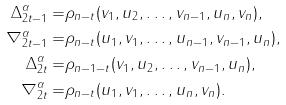<formula> <loc_0><loc_0><loc_500><loc_500>\Delta ^ { \alpha } _ { 2 t - 1 } = & \rho _ { n - t } ( v _ { 1 } , u _ { 2 } , \dots , v _ { n - 1 } , u _ { n } , v _ { n } ) , \\ \nabla ^ { \alpha } _ { 2 t - 1 } = & \rho _ { n - t } ( u _ { 1 } , v _ { 1 } , \dots , u _ { n - 1 } , v _ { n - 1 } , u _ { n } ) , \\ \Delta ^ { \alpha } _ { 2 t } = & \rho _ { n - 1 - t } ( v _ { 1 } , u _ { 2 } , \dots , v _ { n - 1 } , u _ { n } ) , \\ \nabla ^ { \alpha } _ { 2 t } = & \rho _ { n - t } ( u _ { 1 } , v _ { 1 } , \dots , u _ { n } , v _ { n } ) .</formula> 